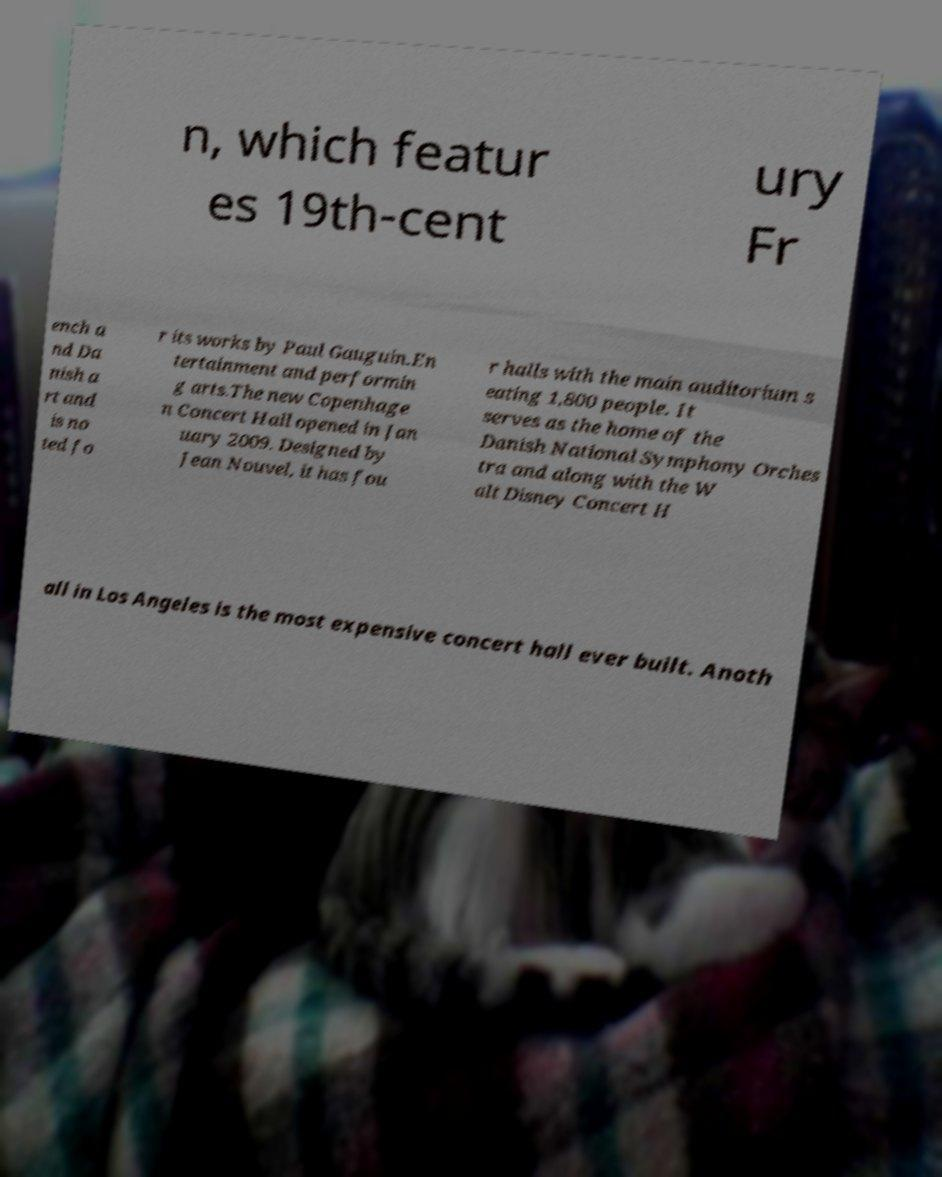Can you read and provide the text displayed in the image?This photo seems to have some interesting text. Can you extract and type it out for me? n, which featur es 19th-cent ury Fr ench a nd Da nish a rt and is no ted fo r its works by Paul Gauguin.En tertainment and performin g arts.The new Copenhage n Concert Hall opened in Jan uary 2009. Designed by Jean Nouvel, it has fou r halls with the main auditorium s eating 1,800 people. It serves as the home of the Danish National Symphony Orches tra and along with the W alt Disney Concert H all in Los Angeles is the most expensive concert hall ever built. Anoth 